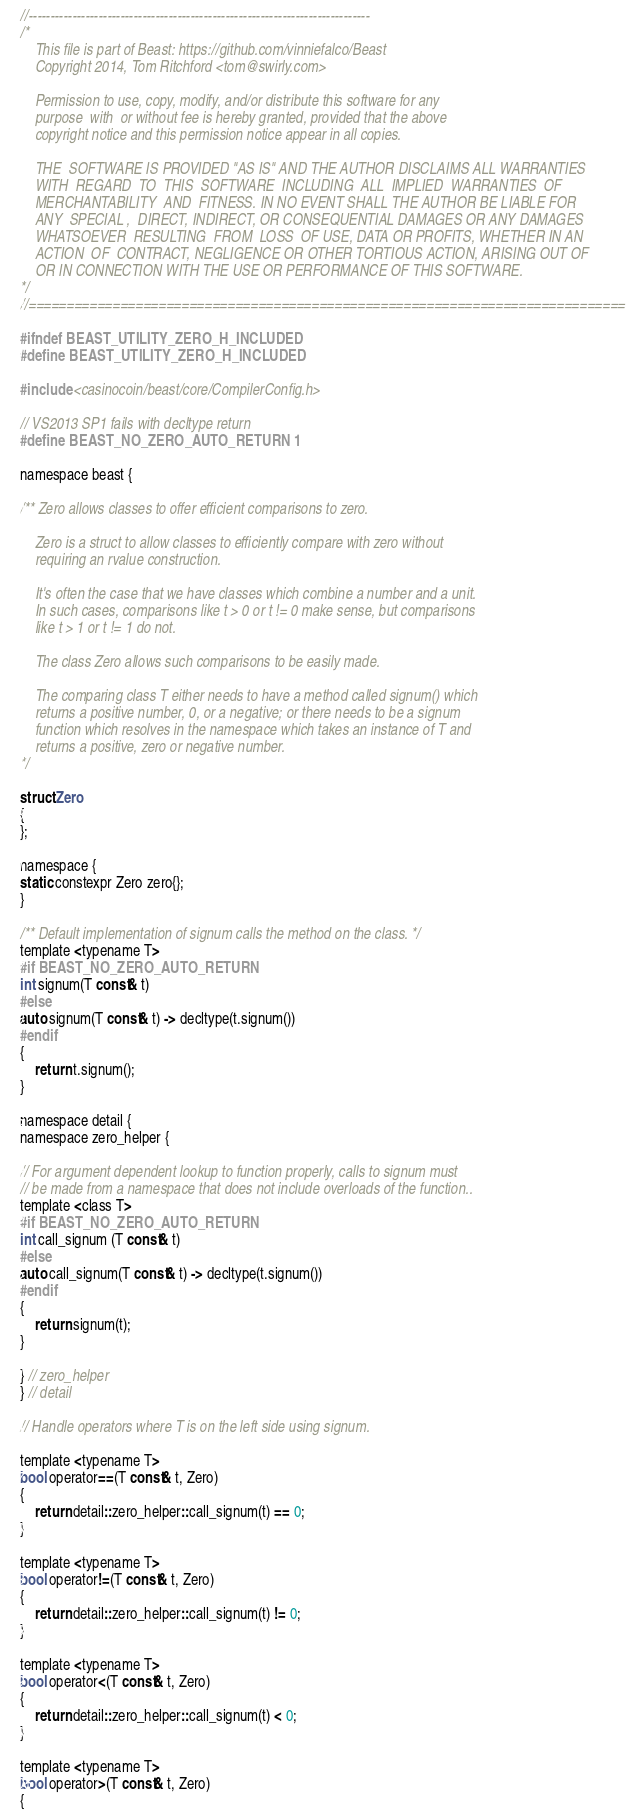Convert code to text. <code><loc_0><loc_0><loc_500><loc_500><_C_>//------------------------------------------------------------------------------
/*
    This file is part of Beast: https://github.com/vinniefalco/Beast
    Copyright 2014, Tom Ritchford <tom@swirly.com>

    Permission to use, copy, modify, and/or distribute this software for any
    purpose  with  or without fee is hereby granted, provided that the above
    copyright notice and this permission notice appear in all copies.

    THE  SOFTWARE IS PROVIDED "AS IS" AND THE AUTHOR DISCLAIMS ALL WARRANTIES
    WITH  REGARD  TO  THIS  SOFTWARE  INCLUDING  ALL  IMPLIED  WARRANTIES  OF
    MERCHANTABILITY  AND  FITNESS. IN NO EVENT SHALL THE AUTHOR BE LIABLE FOR
    ANY  SPECIAL ,  DIRECT, INDIRECT, OR CONSEQUENTIAL DAMAGES OR ANY DAMAGES
    WHATSOEVER  RESULTING  FROM  LOSS  OF USE, DATA OR PROFITS, WHETHER IN AN
    ACTION  OF  CONTRACT, NEGLIGENCE OR OTHER TORTIOUS ACTION, ARISING OUT OF
    OR IN CONNECTION WITH THE USE OR PERFORMANCE OF THIS SOFTWARE.
*/
//==============================================================================

#ifndef BEAST_UTILITY_ZERO_H_INCLUDED
#define BEAST_UTILITY_ZERO_H_INCLUDED

#include <casinocoin/beast/core/CompilerConfig.h>

// VS2013 SP1 fails with decltype return
#define BEAST_NO_ZERO_AUTO_RETURN 1

namespace beast {

/** Zero allows classes to offer efficient comparisons to zero.

    Zero is a struct to allow classes to efficiently compare with zero without
    requiring an rvalue construction.

    It's often the case that we have classes which combine a number and a unit.
    In such cases, comparisons like t > 0 or t != 0 make sense, but comparisons
    like t > 1 or t != 1 do not.

    The class Zero allows such comparisons to be easily made.

    The comparing class T either needs to have a method called signum() which
    returns a positive number, 0, or a negative; or there needs to be a signum
    function which resolves in the namespace which takes an instance of T and
    returns a positive, zero or negative number.
*/

struct Zero
{
};

namespace {
static constexpr Zero zero{};
}

/** Default implementation of signum calls the method on the class. */
template <typename T>
#if BEAST_NO_ZERO_AUTO_RETURN
int signum(T const& t)
#else
auto signum(T const& t) -> decltype(t.signum())
#endif
{
    return t.signum();
}

namespace detail {
namespace zero_helper {

// For argument dependent lookup to function properly, calls to signum must
// be made from a namespace that does not include overloads of the function..
template <class T>
#if BEAST_NO_ZERO_AUTO_RETURN
int call_signum (T const& t)
#else
auto call_signum(T const& t) -> decltype(t.signum())
#endif
{
    return signum(t);
}

} // zero_helper
} // detail

// Handle operators where T is on the left side using signum.

template <typename T>
bool operator==(T const& t, Zero)
{
    return detail::zero_helper::call_signum(t) == 0;
}

template <typename T>
bool operator!=(T const& t, Zero)
{
    return detail::zero_helper::call_signum(t) != 0;
}

template <typename T>
bool operator<(T const& t, Zero)
{
    return detail::zero_helper::call_signum(t) < 0;
}

template <typename T>
bool operator>(T const& t, Zero)
{</code> 